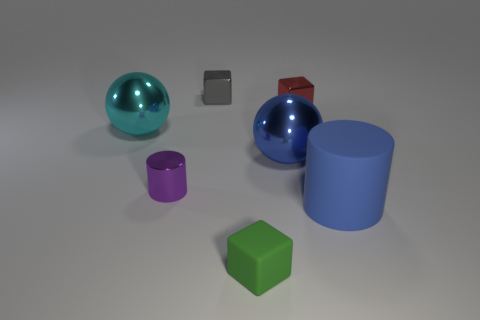Add 2 metallic spheres. How many objects exist? 9 Subtract all cylinders. How many objects are left? 5 Subtract 0 green spheres. How many objects are left? 7 Subtract all blue shiny objects. Subtract all gray shiny cubes. How many objects are left? 5 Add 5 balls. How many balls are left? 7 Add 6 large cyan matte objects. How many large cyan matte objects exist? 6 